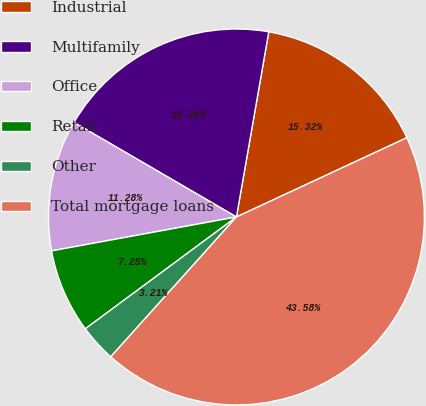<chart> <loc_0><loc_0><loc_500><loc_500><pie_chart><fcel>Industrial<fcel>Multifamily<fcel>Office<fcel>Retail<fcel>Other<fcel>Total mortgage loans<nl><fcel>15.32%<fcel>19.36%<fcel>11.28%<fcel>7.25%<fcel>3.21%<fcel>43.58%<nl></chart> 